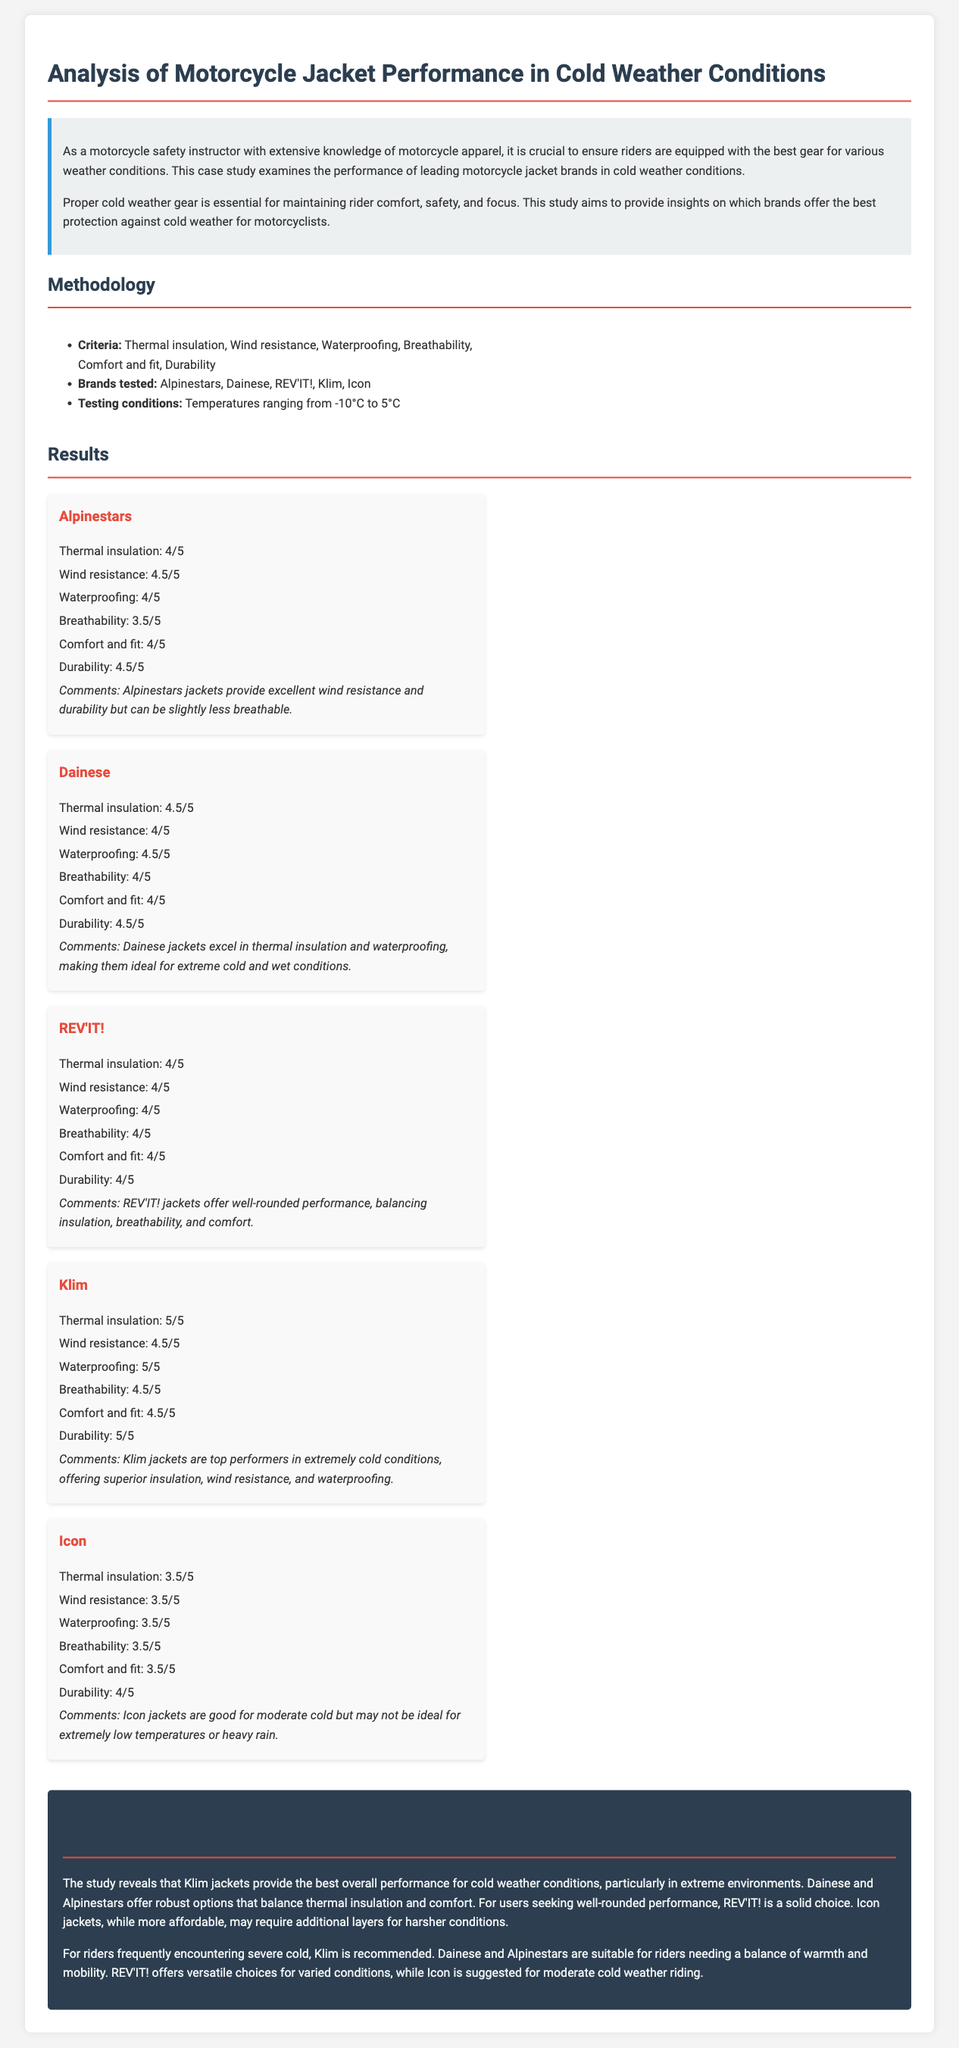What is the primary focus of the case study? The case study focuses on analyzing the performance of motorcycle jackets in cold weather conditions.
Answer: Performance of motorcycle jackets in cold weather conditions Which brand received the highest score for thermal insulation? Klim received the highest score of 5/5 for thermal insulation in the results section.
Answer: Klim What temperature range was used for testing the jackets? The jackets were tested in temperatures ranging from -10°C to 5°C.
Answer: -10°C to 5°C Which brand is recommended for riders frequently encountering severe cold? The recommendation for severe cold is Klim jackets.
Answer: Klim What score did REV'IT! receive for breathability? REV'IT! received a score of 4/5 for breathability.
Answer: 4/5 Which two brands were noted for balancing thermal insulation and comfort? Dainese and Alpinestars are noted for balancing thermal insulation and comfort.
Answer: Dainese and Alpinestars What aspect did Icon jackets score the lowest in? Icon jackets scored the lowest in thermal insulation with 3.5/5.
Answer: Thermal insulation What is the overall conclusion regarding Klim jackets? Klim jackets are the best overall performers in cold weather conditions.
Answer: Best overall performers Which brand excels in waterproofing according to the results? Dainese excelled in waterproofing with a score of 4.5/5.
Answer: Dainese 